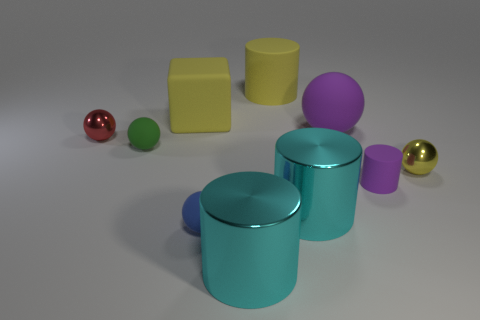Subtract all blue spheres. How many spheres are left? 4 Subtract all yellow cylinders. How many cylinders are left? 3 Subtract 3 balls. How many balls are left? 2 Subtract all cylinders. How many objects are left? 6 Subtract all brown blocks. How many purple balls are left? 1 Subtract all yellow rubber objects. Subtract all red spheres. How many objects are left? 7 Add 7 purple cylinders. How many purple cylinders are left? 8 Add 1 purple cylinders. How many purple cylinders exist? 2 Subtract 0 blue cylinders. How many objects are left? 10 Subtract all purple balls. Subtract all purple blocks. How many balls are left? 4 